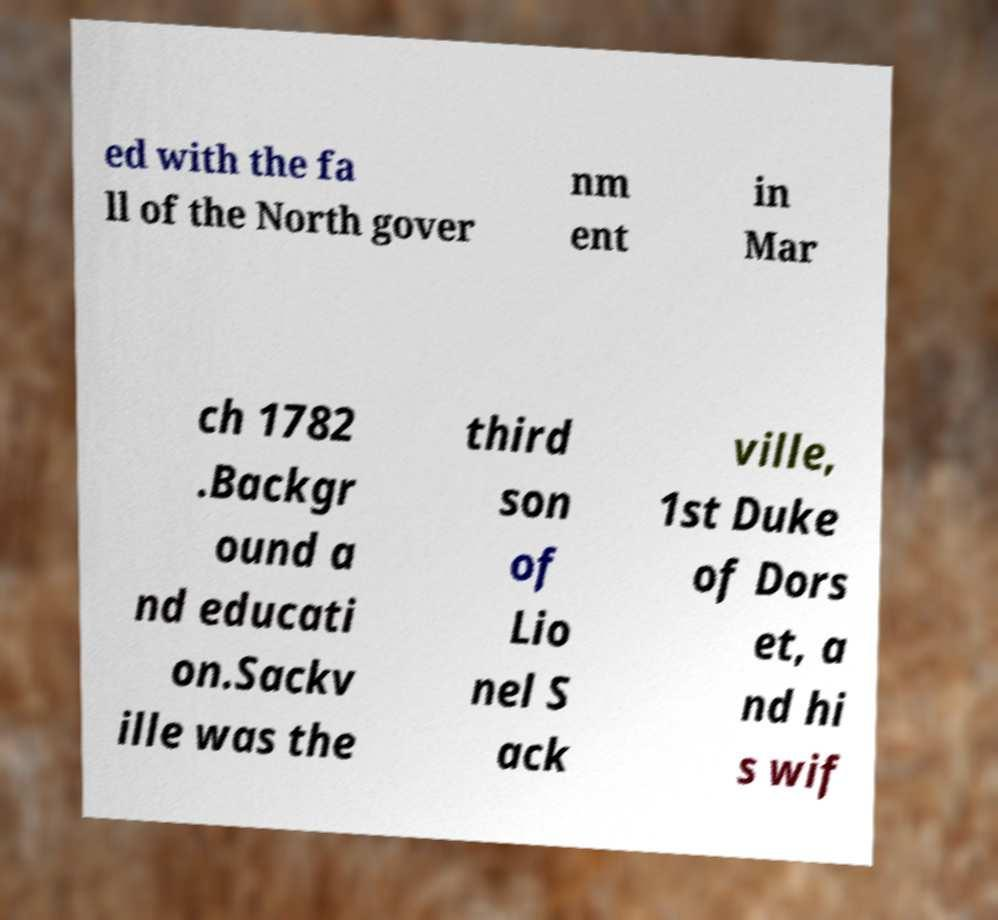Can you accurately transcribe the text from the provided image for me? ed with the fa ll of the North gover nm ent in Mar ch 1782 .Backgr ound a nd educati on.Sackv ille was the third son of Lio nel S ack ville, 1st Duke of Dors et, a nd hi s wif 